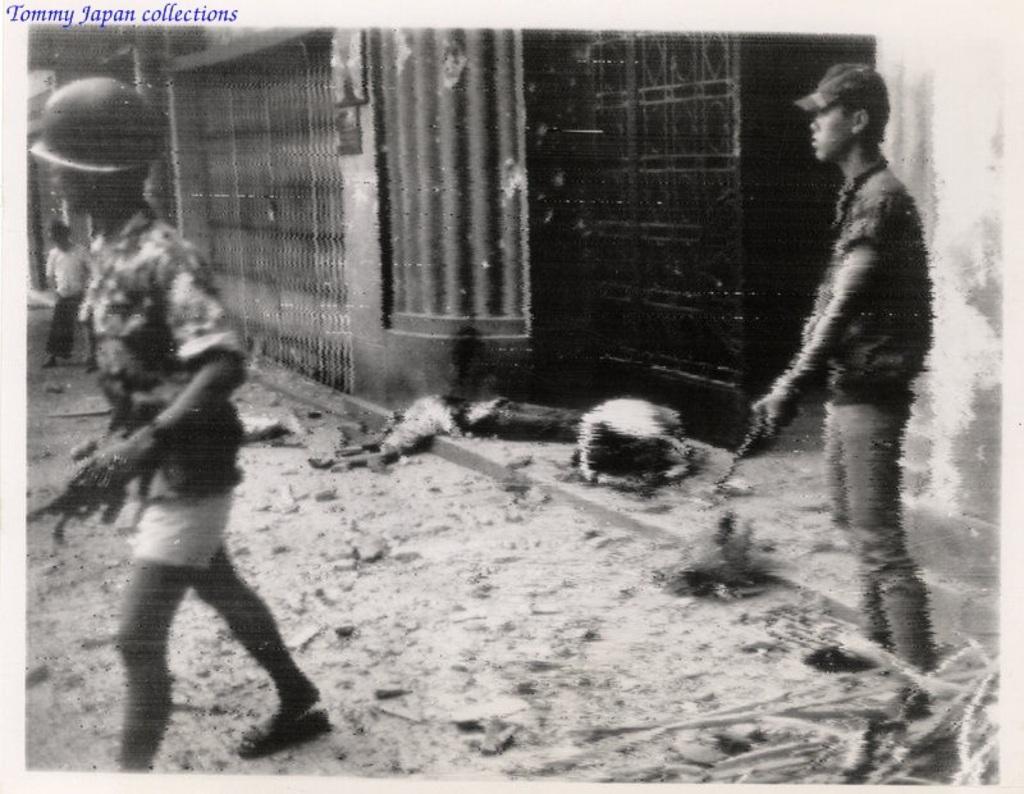Could you give a brief overview of what you see in this image? It is a black and white image, in the middle it is a house. On the left side a man is walking by holding the gun in his hand, on right side a man is standing by holding a weapon in his hand. 